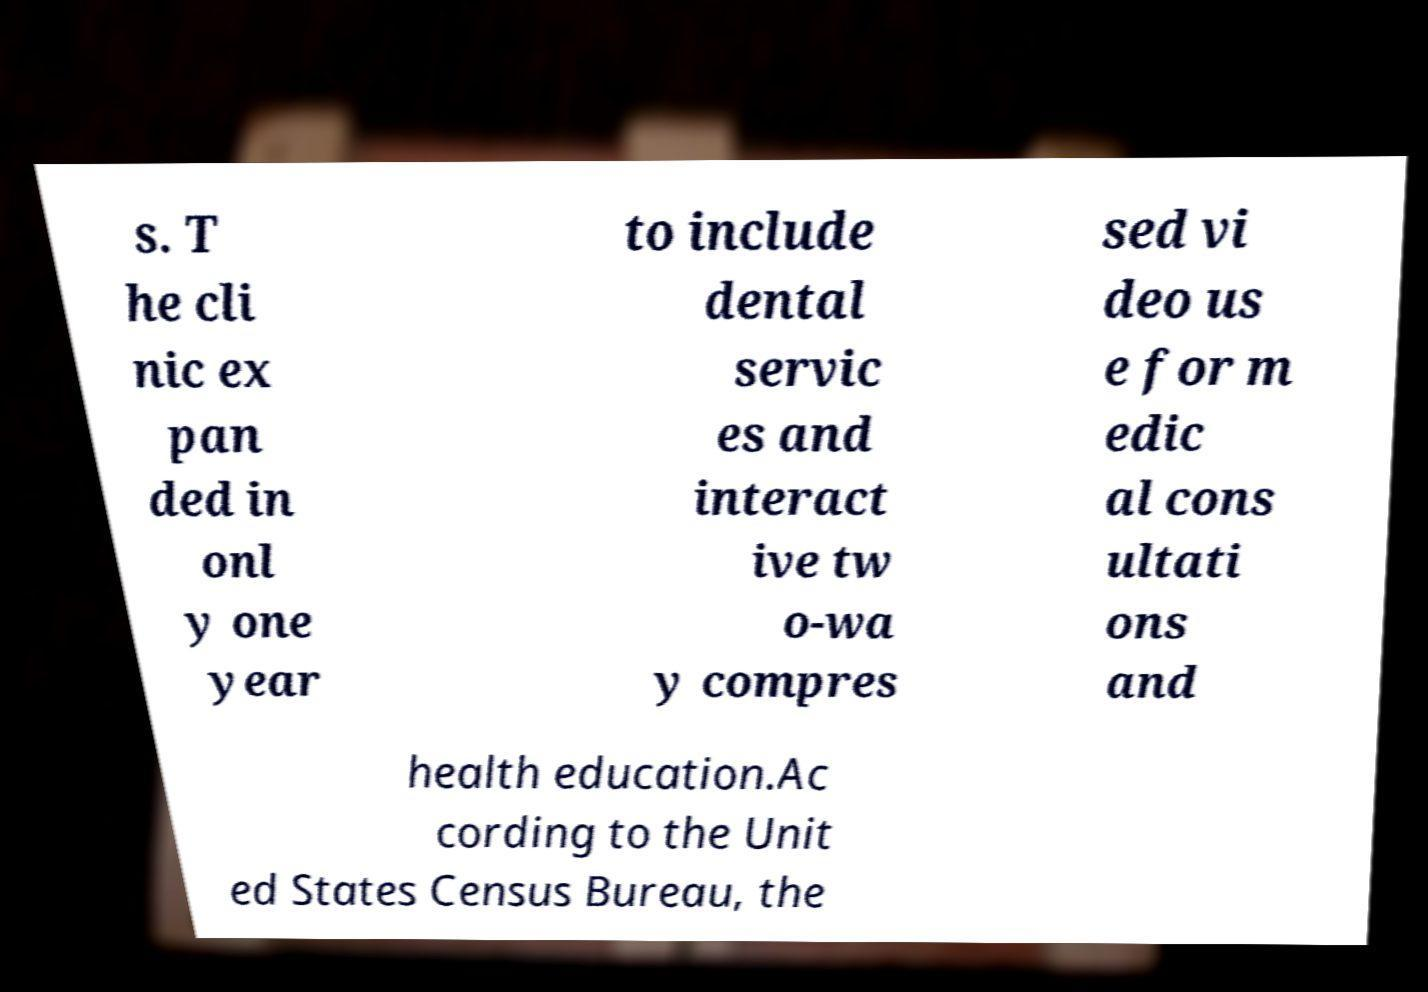Could you assist in decoding the text presented in this image and type it out clearly? s. T he cli nic ex pan ded in onl y one year to include dental servic es and interact ive tw o-wa y compres sed vi deo us e for m edic al cons ultati ons and health education.Ac cording to the Unit ed States Census Bureau, the 